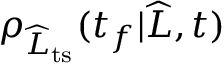<formula> <loc_0><loc_0><loc_500><loc_500>\rho _ { \widehat { L } _ { t s } } ( t _ { f } | \widehat { L } , t )</formula> 